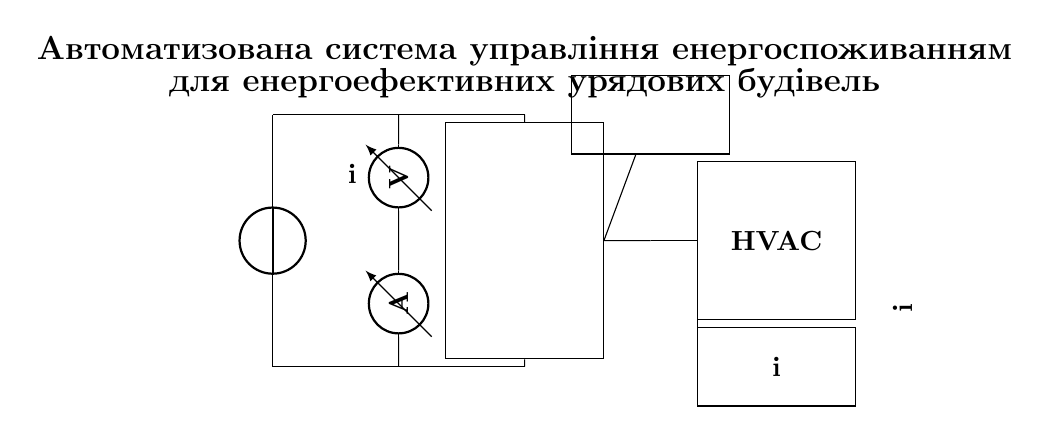What is the main power supply in this circuit? The main power supply is labeled as "Мережа," which is the source of the circuit's power.
Answer: Мережа What component measures current in this system? The current measurement is done by the "Розумний" which is shown as an ammeter in the circuit diagram.
Answer: Розумний How many sensors are depicted in the circuit? The diagram shows one block labeled "Датчики," indicating there is one unit of sensors used in the circuit.
Answer: Один What type of system does the circuit control? The circuit controls energy-efficient systems, as indicated by the label "Енергоефективні системи."
Answer: Енергоефективні системи Which components are connected to the control unit? The control unit is connected to the sensors, HVAC system, and lighting system, indicating it manages all these components.
Answer: Датчики, HVAC, Освітлення What is the role of the HVAC system in this circuit? The HVAC system is responsible for heating, ventilation, and air conditioning, helping to maintain energy efficiency within the government buildings.
Answer: Опалення, вентиляція та кондиціонування What is the title of the automated system as depicted in the circuit? The title is "Автоматизована система управління енергоспоживанням для енергоефективних урядових будівель," outlining the purpose of the circuit.
Answer: Автоматизована система управління енергоспоживанням 